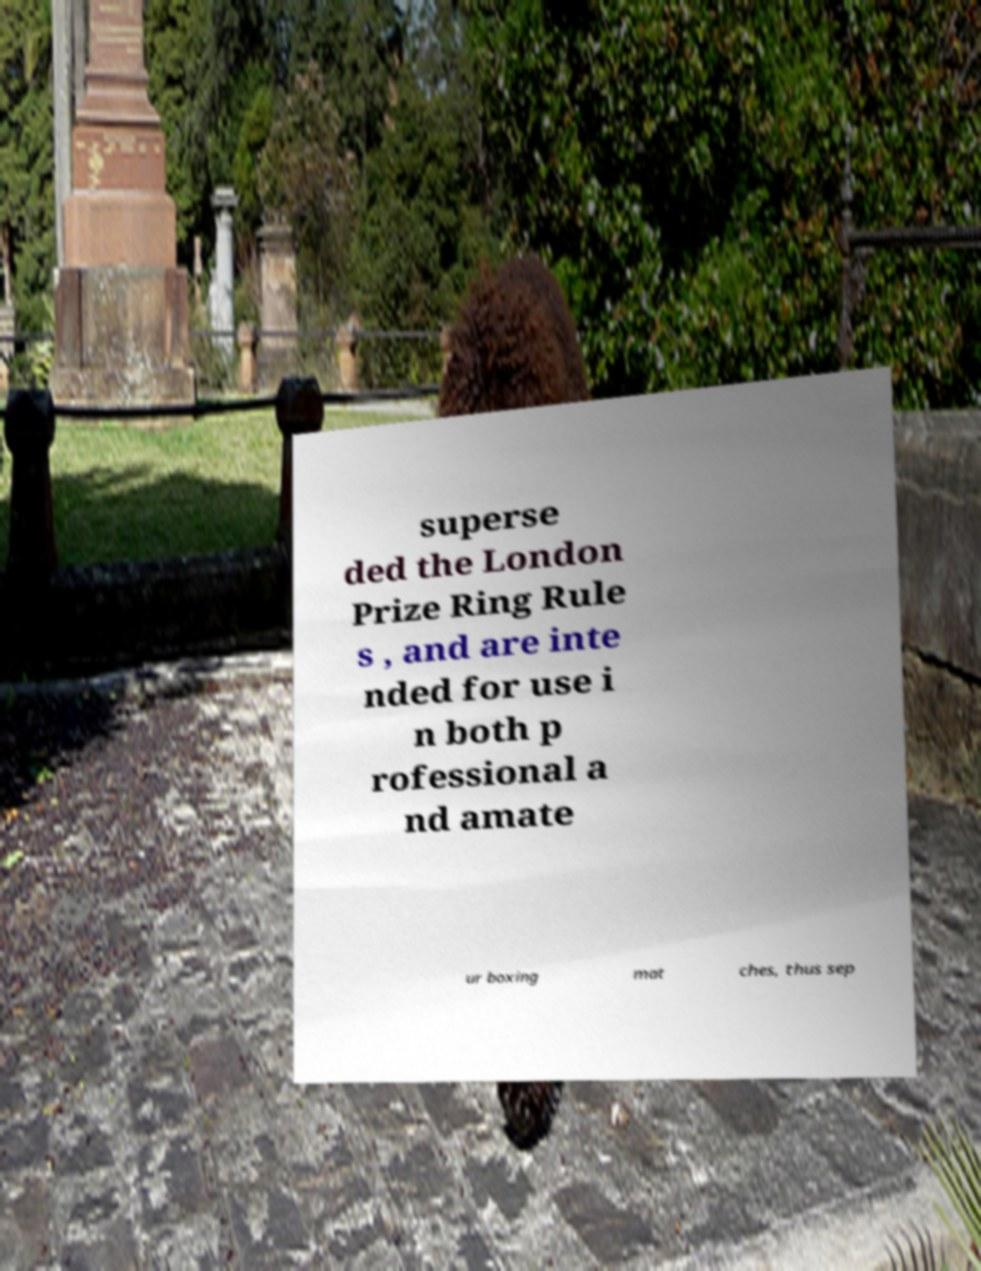Please read and relay the text visible in this image. What does it say? superse ded the London Prize Ring Rule s , and are inte nded for use i n both p rofessional a nd amate ur boxing mat ches, thus sep 